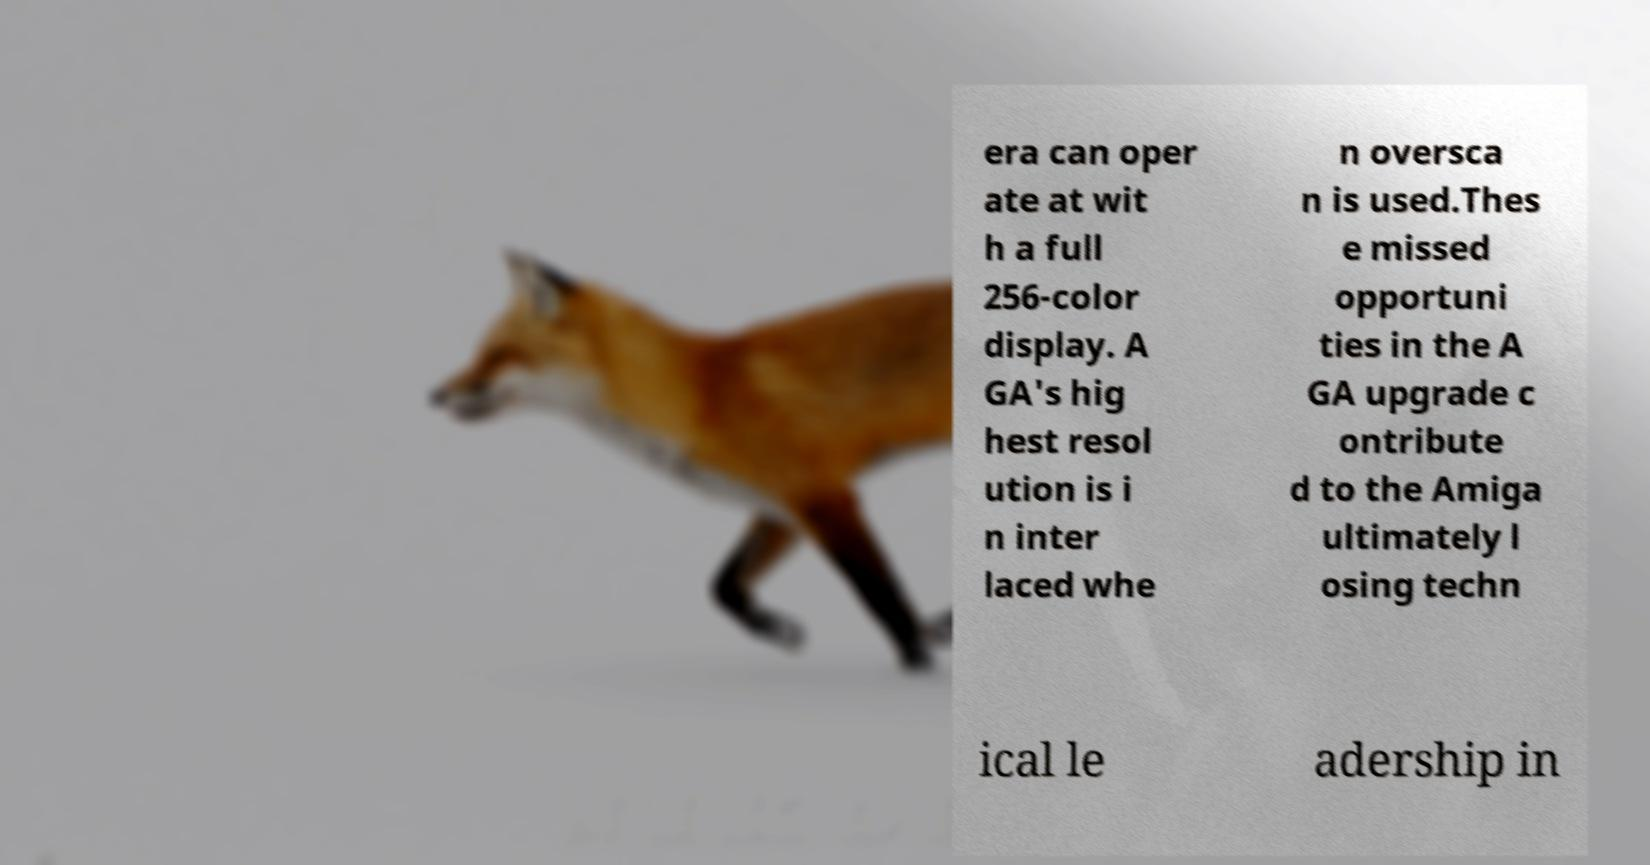Could you assist in decoding the text presented in this image and type it out clearly? era can oper ate at wit h a full 256-color display. A GA's hig hest resol ution is i n inter laced whe n oversca n is used.Thes e missed opportuni ties in the A GA upgrade c ontribute d to the Amiga ultimately l osing techn ical le adership in 